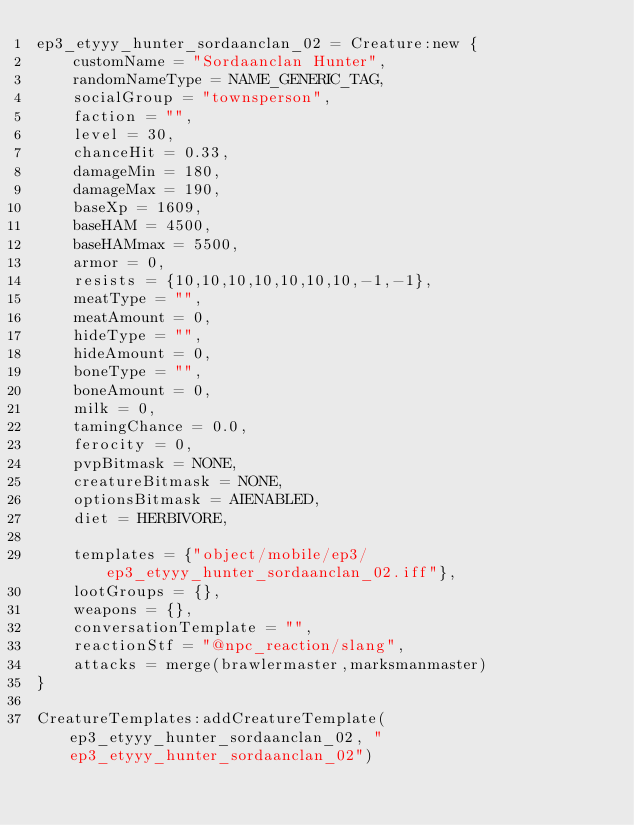<code> <loc_0><loc_0><loc_500><loc_500><_Lua_>ep3_etyyy_hunter_sordaanclan_02 = Creature:new {
	customName = "Sordaanclan Hunter",
	randomNameType = NAME_GENERIC_TAG,
	socialGroup = "townsperson",
	faction = "",
	level = 30,
	chanceHit = 0.33,
	damageMin = 180,
	damageMax = 190,
	baseXp = 1609,
	baseHAM = 4500,
	baseHAMmax = 5500,
	armor = 0,
	resists = {10,10,10,10,10,10,10,-1,-1},
	meatType = "",
	meatAmount = 0,
	hideType = "",
	hideAmount = 0,
	boneType = "",
	boneAmount = 0,
	milk = 0,
	tamingChance = 0.0,
	ferocity = 0,
	pvpBitmask = NONE,
	creatureBitmask = NONE,
	optionsBitmask = AIENABLED,
	diet = HERBIVORE,

	templates = {"object/mobile/ep3/ep3_etyyy_hunter_sordaanclan_02.iff"},
	lootGroups = {},
	weapons = {},
	conversationTemplate = "",
	reactionStf = "@npc_reaction/slang",
	attacks = merge(brawlermaster,marksmanmaster)
}

CreatureTemplates:addCreatureTemplate(ep3_etyyy_hunter_sordaanclan_02, "ep3_etyyy_hunter_sordaanclan_02")
</code> 